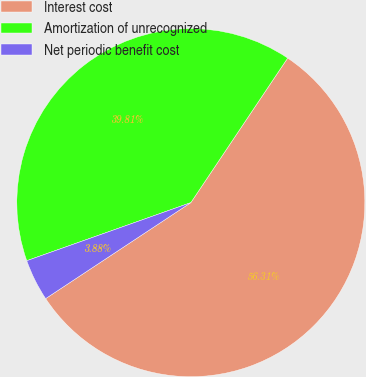<chart> <loc_0><loc_0><loc_500><loc_500><pie_chart><fcel>Interest cost<fcel>Amortization of unrecognized<fcel>Net periodic benefit cost<nl><fcel>56.31%<fcel>39.81%<fcel>3.88%<nl></chart> 